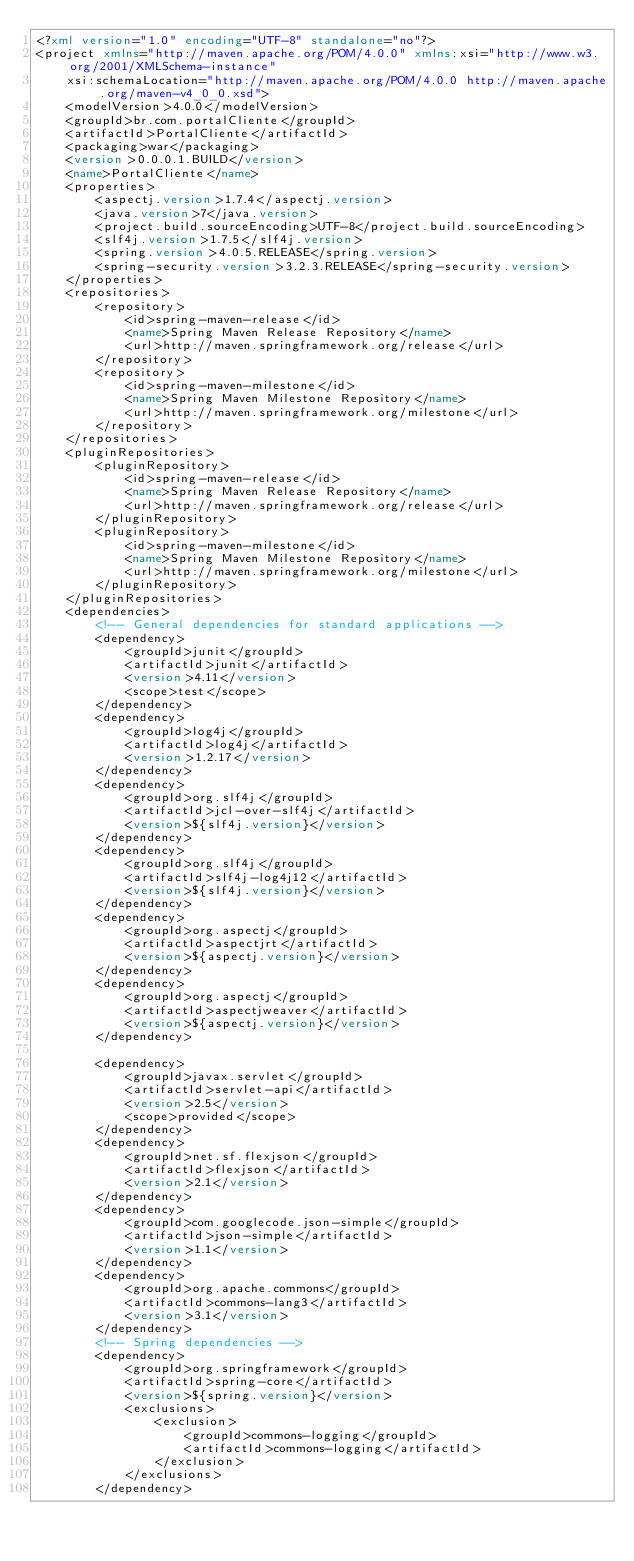<code> <loc_0><loc_0><loc_500><loc_500><_XML_><?xml version="1.0" encoding="UTF-8" standalone="no"?>
<project xmlns="http://maven.apache.org/POM/4.0.0" xmlns:xsi="http://www.w3.org/2001/XMLSchema-instance"
	xsi:schemaLocation="http://maven.apache.org/POM/4.0.0 http://maven.apache.org/maven-v4_0_0.xsd">
	<modelVersion>4.0.0</modelVersion>
	<groupId>br.com.portalCliente</groupId>
	<artifactId>PortalCliente</artifactId>
	<packaging>war</packaging>
	<version>0.0.0.1.BUILD</version>
	<name>PortalCliente</name>
	<properties>
		<aspectj.version>1.7.4</aspectj.version>
		<java.version>7</java.version>
		<project.build.sourceEncoding>UTF-8</project.build.sourceEncoding>
		<slf4j.version>1.7.5</slf4j.version>
		<spring.version>4.0.5.RELEASE</spring.version>
		<spring-security.version>3.2.3.RELEASE</spring-security.version>
	</properties>
	<repositories>
		<repository>
			<id>spring-maven-release</id>
			<name>Spring Maven Release Repository</name>
			<url>http://maven.springframework.org/release</url>
		</repository>
		<repository>
			<id>spring-maven-milestone</id>
			<name>Spring Maven Milestone Repository</name>
			<url>http://maven.springframework.org/milestone</url>
		</repository>
	</repositories>
	<pluginRepositories>
		<pluginRepository>
			<id>spring-maven-release</id>
			<name>Spring Maven Release Repository</name>
			<url>http://maven.springframework.org/release</url>
		</pluginRepository>
		<pluginRepository>
			<id>spring-maven-milestone</id>
			<name>Spring Maven Milestone Repository</name>
			<url>http://maven.springframework.org/milestone</url>
		</pluginRepository>
	</pluginRepositories>
	<dependencies>
		<!-- General dependencies for standard applications -->
		<dependency>
			<groupId>junit</groupId>
			<artifactId>junit</artifactId>
			<version>4.11</version>
			<scope>test</scope>
		</dependency>
		<dependency>
			<groupId>log4j</groupId>
			<artifactId>log4j</artifactId>
			<version>1.2.17</version>
		</dependency>
		<dependency>
			<groupId>org.slf4j</groupId>
			<artifactId>jcl-over-slf4j</artifactId>
			<version>${slf4j.version}</version>
		</dependency>
		<dependency>
			<groupId>org.slf4j</groupId>
			<artifactId>slf4j-log4j12</artifactId>
			<version>${slf4j.version}</version>
		</dependency>
		<dependency>
			<groupId>org.aspectj</groupId>
			<artifactId>aspectjrt</artifactId>
			<version>${aspectj.version}</version>
		</dependency>
		<dependency>
			<groupId>org.aspectj</groupId>
			<artifactId>aspectjweaver</artifactId>
			<version>${aspectj.version}</version>
		</dependency>

		<dependency>
			<groupId>javax.servlet</groupId>
			<artifactId>servlet-api</artifactId>
			<version>2.5</version>
			<scope>provided</scope>
		</dependency>
		<dependency>
			<groupId>net.sf.flexjson</groupId>
			<artifactId>flexjson</artifactId>
			<version>2.1</version>
		</dependency>
		<dependency>
			<groupId>com.googlecode.json-simple</groupId>
			<artifactId>json-simple</artifactId>
			<version>1.1</version>
		</dependency>
		<dependency>
			<groupId>org.apache.commons</groupId>
			<artifactId>commons-lang3</artifactId>
			<version>3.1</version>
		</dependency>
		<!-- Spring dependencies -->
		<dependency>
			<groupId>org.springframework</groupId>
			<artifactId>spring-core</artifactId>
			<version>${spring.version}</version>
			<exclusions>
				<exclusion>
					<groupId>commons-logging</groupId>
					<artifactId>commons-logging</artifactId>
				</exclusion>
			</exclusions>
		</dependency></code> 